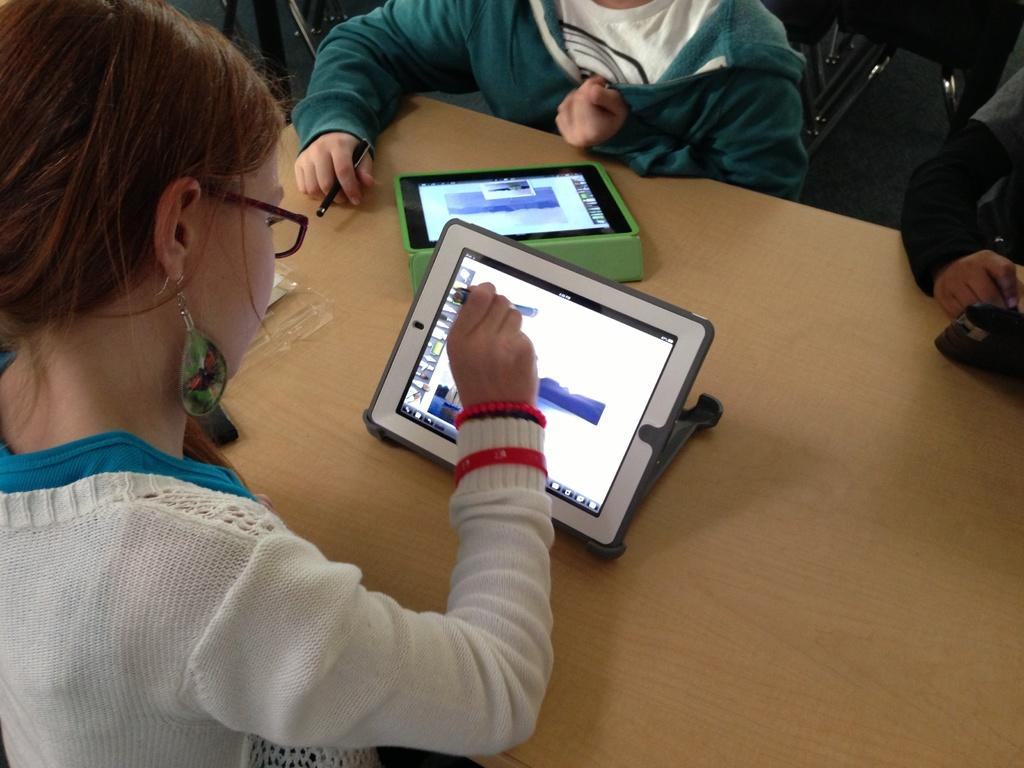Who is present in the image? There are kids in the image. What are the kids doing in the image? The kids are sitting around a table. What objects can be seen on the table? There are electronic gadgets on the table. What type of pancake is being served to the kids in the image? There is no pancake present in the image; the kids are sitting around a table with electronic gadgets. 